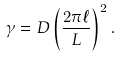Convert formula to latex. <formula><loc_0><loc_0><loc_500><loc_500>\gamma = D \left ( \frac { 2 \pi \ell } { L } \right ) ^ { 2 } .</formula> 